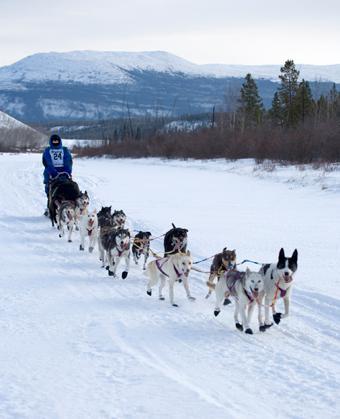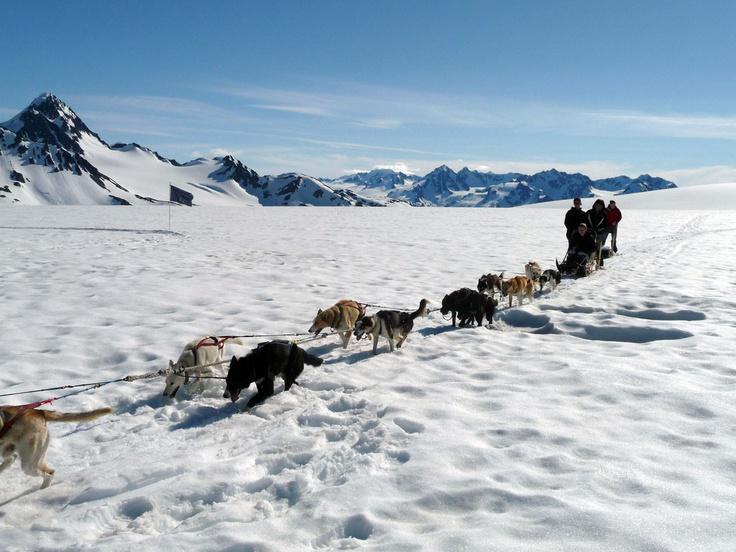The first image is the image on the left, the second image is the image on the right. For the images displayed, is the sentence "The dog team in the left image is heading right, and the dog team in the right image is heading left." factually correct? Answer yes or no. Yes. The first image is the image on the left, the second image is the image on the right. For the images displayed, is the sentence "In one of the images, a dogsled is headed towards the left." factually correct? Answer yes or no. Yes. 